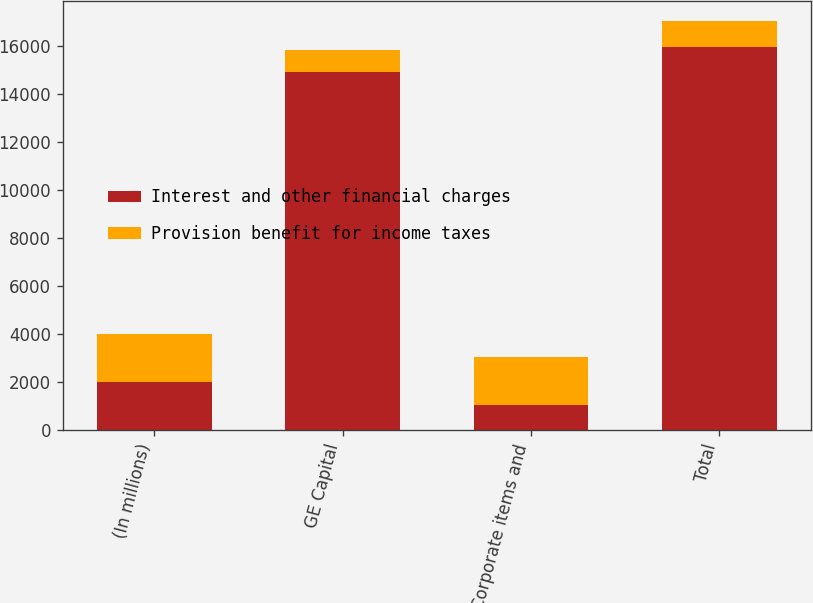<chart> <loc_0><loc_0><loc_500><loc_500><stacked_bar_chart><ecel><fcel>(In millions)<fcel>GE Capital<fcel>Corporate items and<fcel>Total<nl><fcel>Interest and other financial charges<fcel>2010<fcel>14924<fcel>1059<fcel>15983<nl><fcel>Provision benefit for income taxes<fcel>2010<fcel>932<fcel>1982<fcel>1050<nl></chart> 